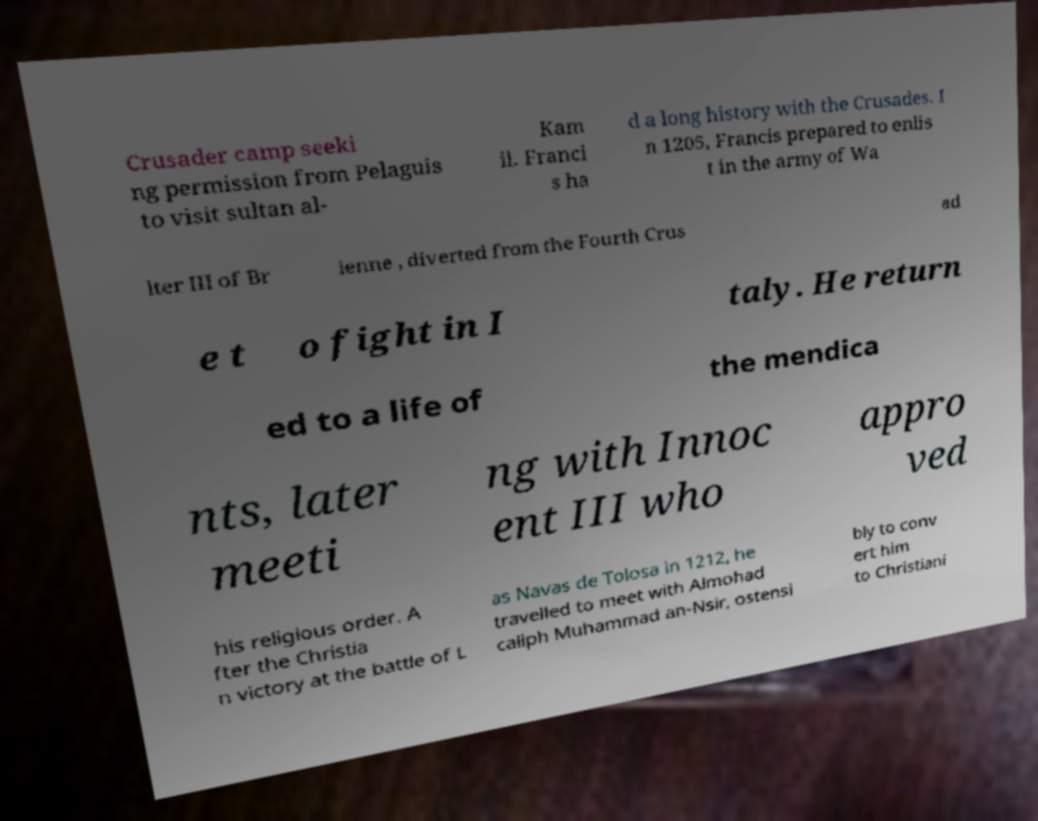I need the written content from this picture converted into text. Can you do that? Crusader camp seeki ng permission from Pelaguis to visit sultan al- Kam il. Franci s ha d a long history with the Crusades. I n 1205, Francis prepared to enlis t in the army of Wa lter III of Br ienne , diverted from the Fourth Crus ad e t o fight in I taly. He return ed to a life of the mendica nts, later meeti ng with Innoc ent III who appro ved his religious order. A fter the Christia n victory at the battle of L as Navas de Tolosa in 1212, he travelled to meet with Almohad caliph Muhammad an-Nsir, ostensi bly to conv ert him to Christiani 